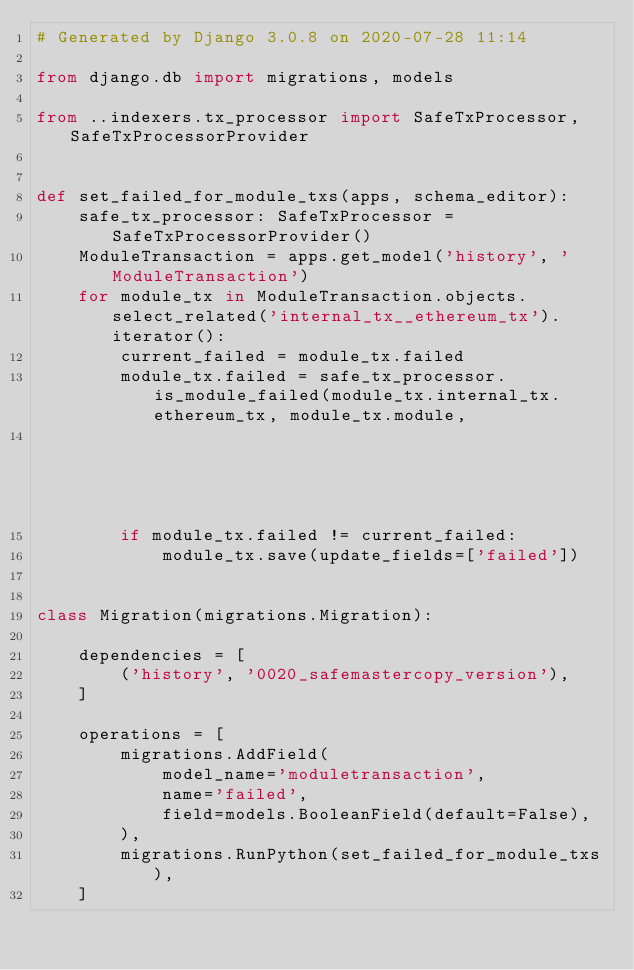Convert code to text. <code><loc_0><loc_0><loc_500><loc_500><_Python_># Generated by Django 3.0.8 on 2020-07-28 11:14

from django.db import migrations, models

from ..indexers.tx_processor import SafeTxProcessor, SafeTxProcessorProvider


def set_failed_for_module_txs(apps, schema_editor):
    safe_tx_processor: SafeTxProcessor = SafeTxProcessorProvider()
    ModuleTransaction = apps.get_model('history', 'ModuleTransaction')
    for module_tx in ModuleTransaction.objects.select_related('internal_tx__ethereum_tx').iterator():
        current_failed = module_tx.failed
        module_tx.failed = safe_tx_processor.is_module_failed(module_tx.internal_tx.ethereum_tx, module_tx.module,
                                                              module_tx.safe)
        if module_tx.failed != current_failed:
            module_tx.save(update_fields=['failed'])


class Migration(migrations.Migration):

    dependencies = [
        ('history', '0020_safemastercopy_version'),
    ]

    operations = [
        migrations.AddField(
            model_name='moduletransaction',
            name='failed',
            field=models.BooleanField(default=False),
        ),
        migrations.RunPython(set_failed_for_module_txs),
    ]
</code> 